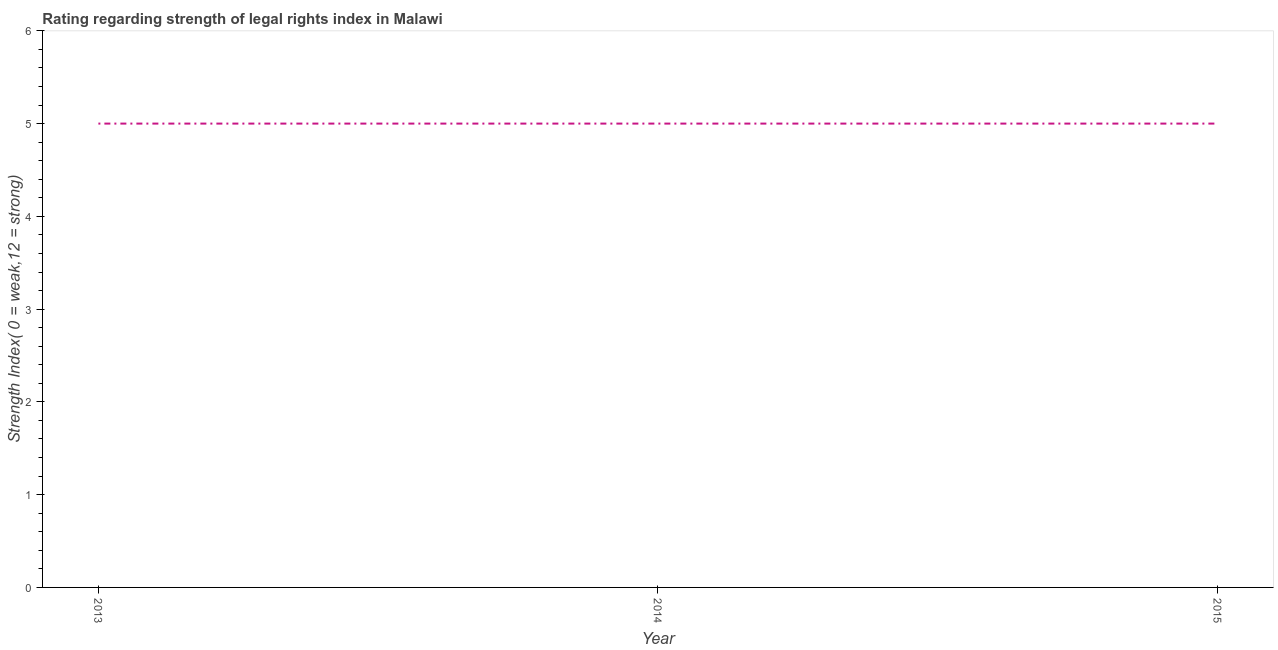What is the strength of legal rights index in 2013?
Offer a terse response. 5. Across all years, what is the maximum strength of legal rights index?
Provide a succinct answer. 5. Across all years, what is the minimum strength of legal rights index?
Ensure brevity in your answer.  5. What is the sum of the strength of legal rights index?
Provide a short and direct response. 15. What is the difference between the strength of legal rights index in 2013 and 2015?
Provide a short and direct response. 0. What is the average strength of legal rights index per year?
Your response must be concise. 5. In how many years, is the strength of legal rights index greater than 1.6 ?
Provide a succinct answer. 3. Do a majority of the years between 2013 and 2014 (inclusive) have strength of legal rights index greater than 4.8 ?
Your answer should be very brief. Yes. Is the strength of legal rights index in 2013 less than that in 2015?
Provide a short and direct response. No. Is the sum of the strength of legal rights index in 2013 and 2015 greater than the maximum strength of legal rights index across all years?
Provide a succinct answer. Yes. What is the difference between the highest and the lowest strength of legal rights index?
Your answer should be very brief. 0. How many years are there in the graph?
Your response must be concise. 3. What is the difference between two consecutive major ticks on the Y-axis?
Keep it short and to the point. 1. Are the values on the major ticks of Y-axis written in scientific E-notation?
Ensure brevity in your answer.  No. What is the title of the graph?
Your response must be concise. Rating regarding strength of legal rights index in Malawi. What is the label or title of the X-axis?
Offer a very short reply. Year. What is the label or title of the Y-axis?
Ensure brevity in your answer.  Strength Index( 0 = weak,12 = strong). What is the Strength Index( 0 = weak,12 = strong) of 2013?
Make the answer very short. 5. What is the Strength Index( 0 = weak,12 = strong) of 2014?
Make the answer very short. 5. What is the difference between the Strength Index( 0 = weak,12 = strong) in 2013 and 2014?
Make the answer very short. 0. What is the difference between the Strength Index( 0 = weak,12 = strong) in 2013 and 2015?
Offer a very short reply. 0. What is the difference between the Strength Index( 0 = weak,12 = strong) in 2014 and 2015?
Offer a terse response. 0. What is the ratio of the Strength Index( 0 = weak,12 = strong) in 2013 to that in 2014?
Offer a terse response. 1. What is the ratio of the Strength Index( 0 = weak,12 = strong) in 2014 to that in 2015?
Provide a succinct answer. 1. 